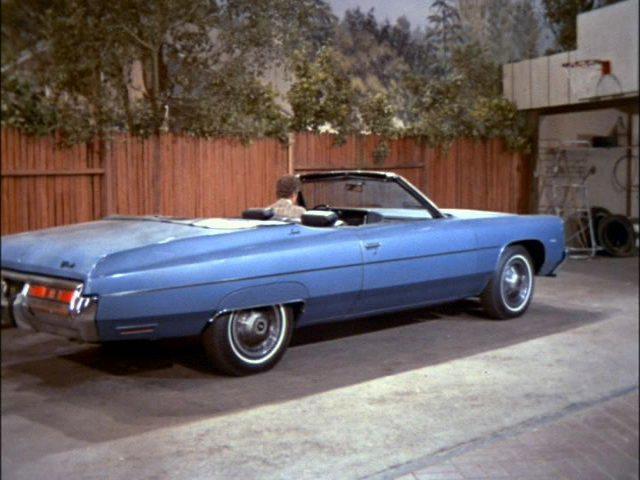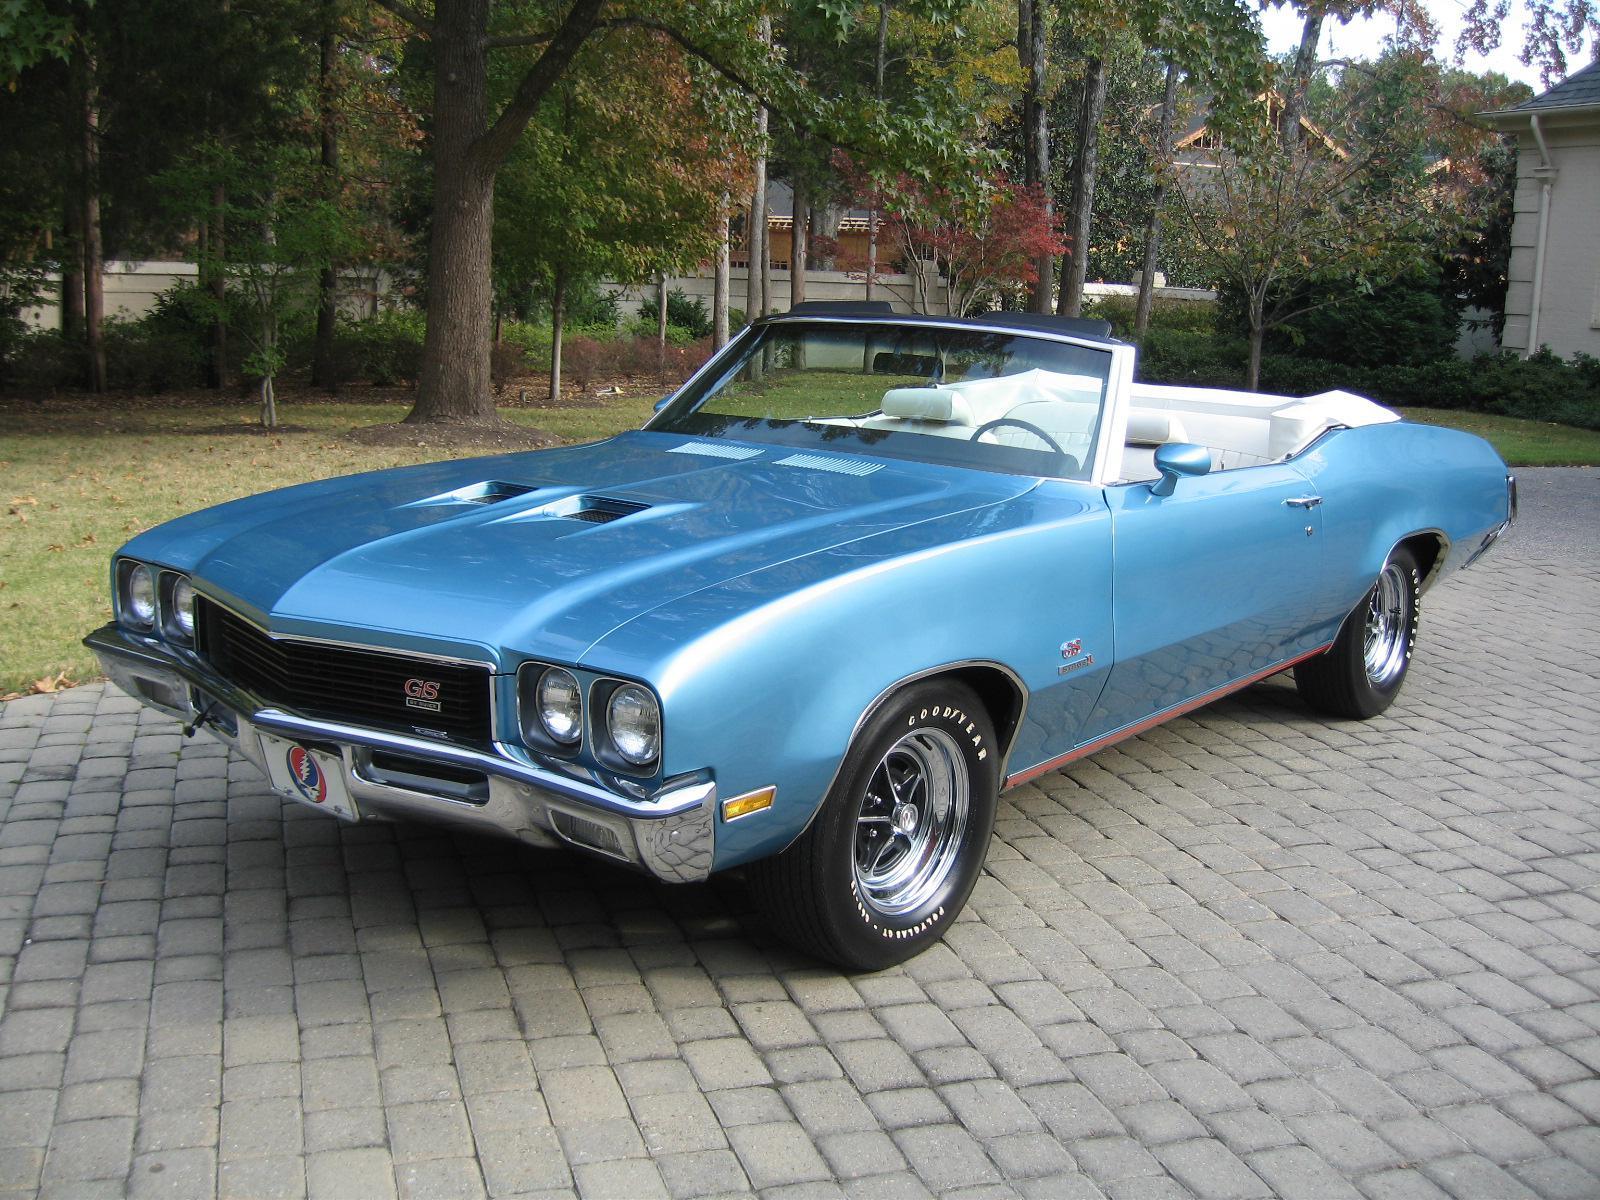The first image is the image on the left, the second image is the image on the right. Examine the images to the left and right. Is the description "One or more of the cars shown are turned to the right." accurate? Answer yes or no. Yes. The first image is the image on the left, the second image is the image on the right. Evaluate the accuracy of this statement regarding the images: "An image shows a convertible car covered with a dark top.". Is it true? Answer yes or no. No. 